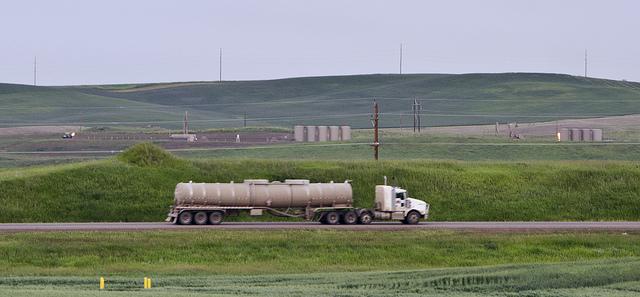How many poles are on the crest of the hill in the background?
Quick response, please. 4. Is there a water body nearby?
Give a very brief answer. No. What type of vehicle is this?
Concise answer only. Truck. How many tires are on the truck?
Be succinct. 14. 